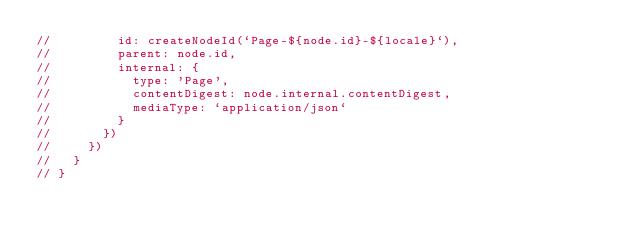<code> <loc_0><loc_0><loc_500><loc_500><_TypeScript_>//         id: createNodeId(`Page-${node.id}-${locale}`),
//         parent: node.id,
//         internal: {
//           type: 'Page',
//           contentDigest: node.internal.contentDigest,
//           mediaType: `application/json`
//         }
//       })
//     })
//   }
// }</code> 